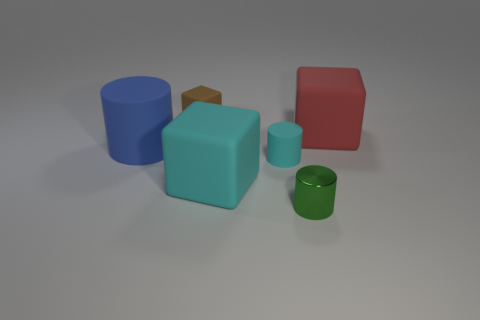Subtract 1 cubes. How many cubes are left? 2 Add 2 large blue cylinders. How many objects exist? 8 Subtract all tiny gray metal cylinders. Subtract all red matte blocks. How many objects are left? 5 Add 1 small cylinders. How many small cylinders are left? 3 Add 4 green spheres. How many green spheres exist? 4 Subtract 0 purple cylinders. How many objects are left? 6 